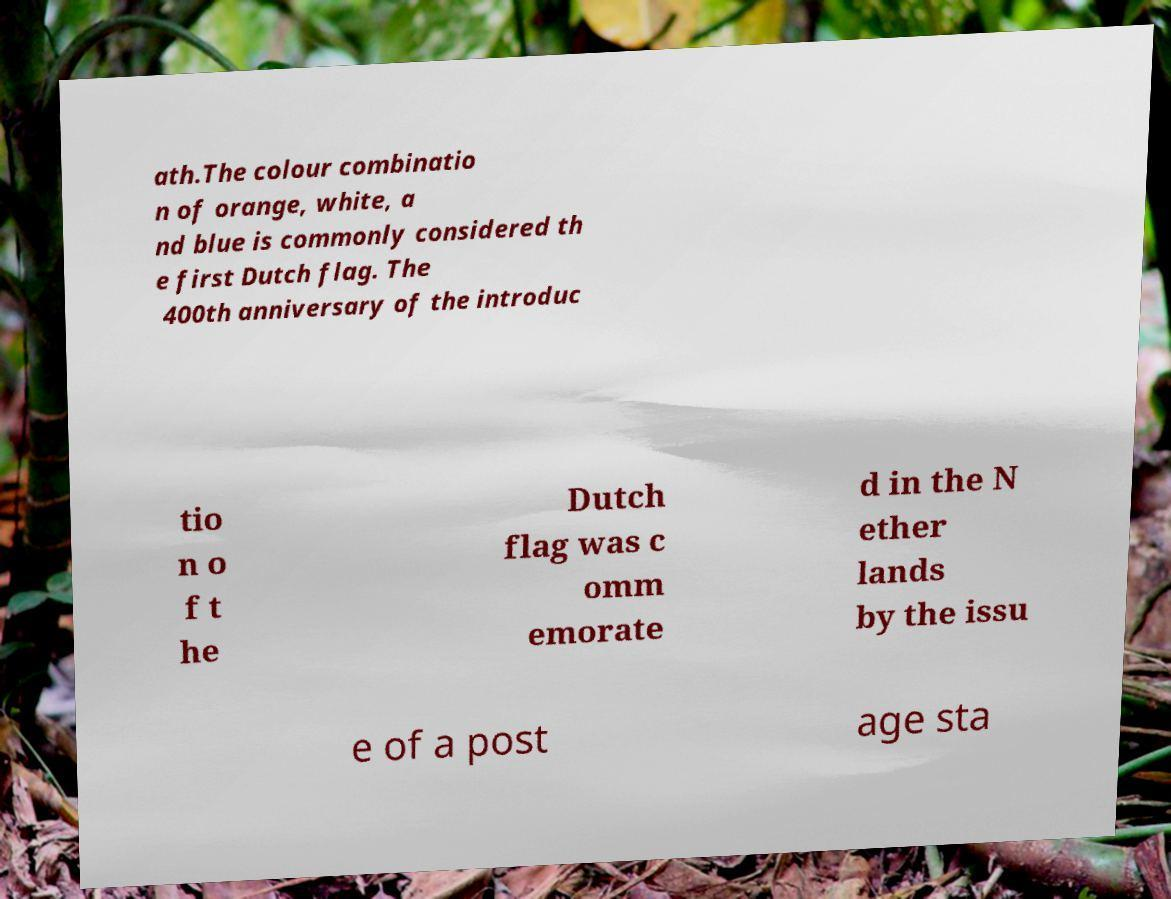Could you extract and type out the text from this image? ath.The colour combinatio n of orange, white, a nd blue is commonly considered th e first Dutch flag. The 400th anniversary of the introduc tio n o f t he Dutch flag was c omm emorate d in the N ether lands by the issu e of a post age sta 